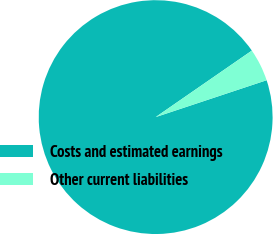<chart> <loc_0><loc_0><loc_500><loc_500><pie_chart><fcel>Costs and estimated earnings<fcel>Other current liabilities<nl><fcel>95.48%<fcel>4.52%<nl></chart> 